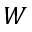<formula> <loc_0><loc_0><loc_500><loc_500>W</formula> 